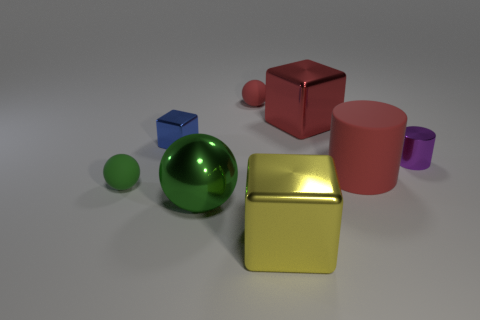The tiny object in front of the big cylinder has what shape?
Make the answer very short. Sphere. The large thing that is made of the same material as the tiny red ball is what shape?
Your response must be concise. Cylinder. Is there any other thing that has the same shape as the tiny red matte thing?
Your answer should be very brief. Yes. There is a tiny blue thing; what number of red spheres are left of it?
Keep it short and to the point. 0. Are there an equal number of large metal blocks on the left side of the tiny green object and brown matte balls?
Offer a terse response. Yes. Do the small cylinder and the red sphere have the same material?
Your answer should be compact. No. How big is the metal thing that is behind the large green metal sphere and in front of the tiny metallic block?
Offer a terse response. Small. What number of red metallic blocks have the same size as the red metal thing?
Make the answer very short. 0. What size is the cube left of the tiny sphere that is behind the tiny blue block?
Provide a succinct answer. Small. There is a small metal object in front of the tiny cube; is its shape the same as the large metallic thing behind the big green sphere?
Your answer should be compact. No. 